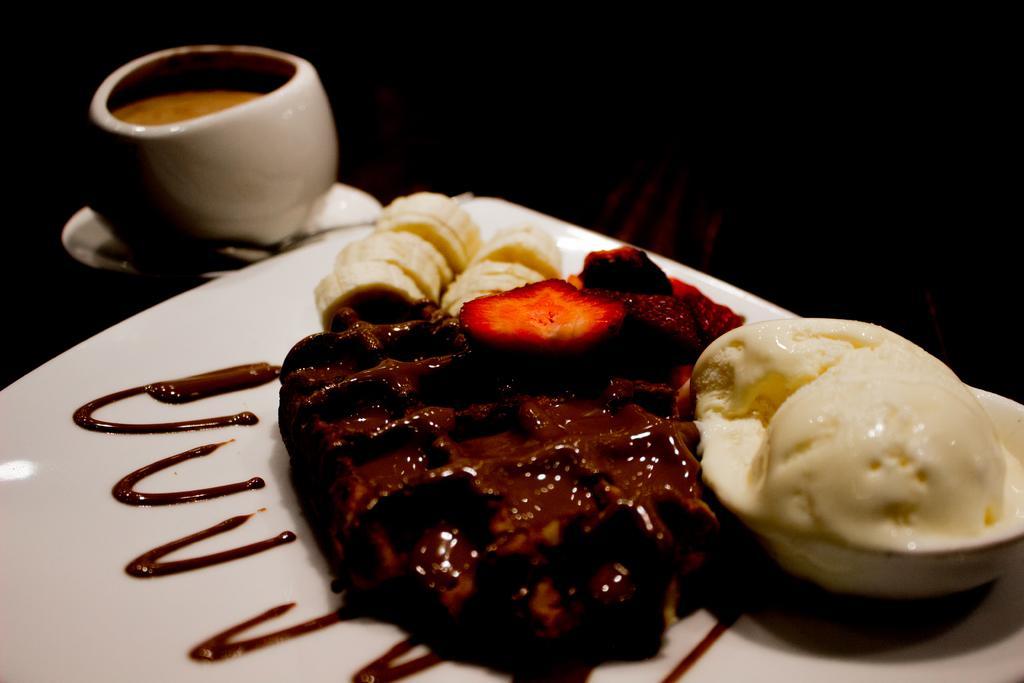In one or two sentences, can you explain what this image depicts? In this image we can see a plate with food item. Near to the plate there is a bowl with some item. And the bowl is on a saucer. In the background it is dark. 